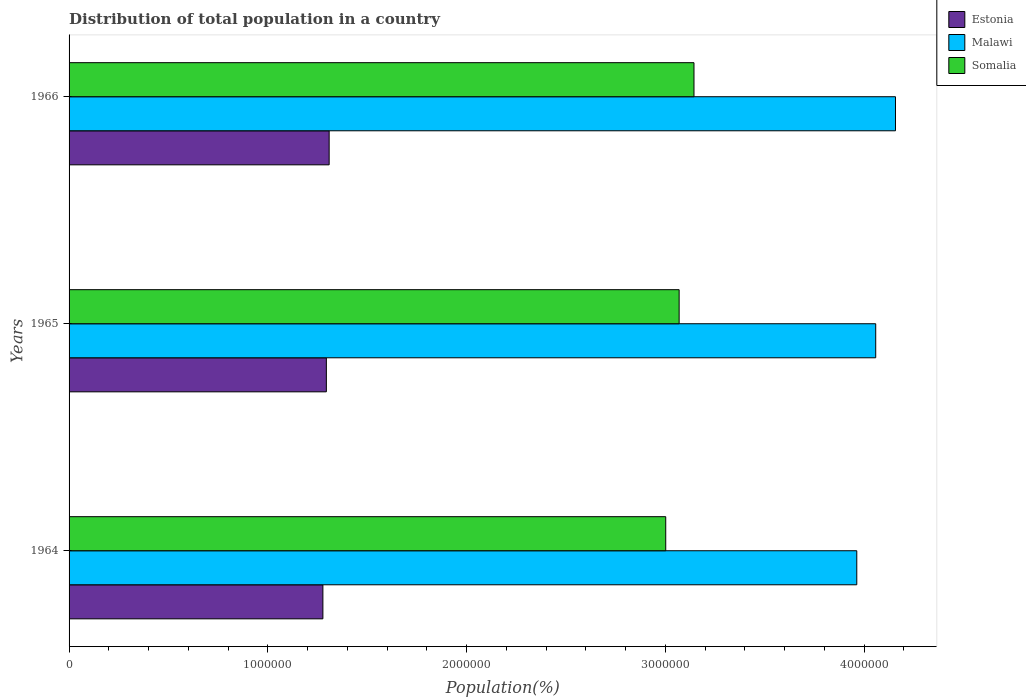Are the number of bars on each tick of the Y-axis equal?
Provide a succinct answer. Yes. How many bars are there on the 3rd tick from the top?
Keep it short and to the point. 3. What is the label of the 1st group of bars from the top?
Provide a succinct answer. 1966. What is the population of in Malawi in 1966?
Give a very brief answer. 4.16e+06. Across all years, what is the maximum population of in Somalia?
Your response must be concise. 3.14e+06. Across all years, what is the minimum population of in Somalia?
Provide a short and direct response. 3.00e+06. In which year was the population of in Somalia maximum?
Offer a terse response. 1966. In which year was the population of in Somalia minimum?
Give a very brief answer. 1964. What is the total population of in Estonia in the graph?
Your response must be concise. 3.88e+06. What is the difference between the population of in Estonia in 1964 and that in 1966?
Provide a short and direct response. -3.15e+04. What is the difference between the population of in Malawi in 1966 and the population of in Estonia in 1964?
Make the answer very short. 2.88e+06. What is the average population of in Malawi per year?
Your answer should be very brief. 4.06e+06. In the year 1964, what is the difference between the population of in Estonia and population of in Malawi?
Keep it short and to the point. -2.69e+06. In how many years, is the population of in Malawi greater than 2200000 %?
Give a very brief answer. 3. What is the ratio of the population of in Somalia in 1964 to that in 1966?
Your response must be concise. 0.95. Is the difference between the population of in Estonia in 1964 and 1966 greater than the difference between the population of in Malawi in 1964 and 1966?
Give a very brief answer. Yes. What is the difference between the highest and the second highest population of in Somalia?
Your response must be concise. 7.47e+04. What is the difference between the highest and the lowest population of in Estonia?
Provide a short and direct response. 3.15e+04. Is the sum of the population of in Somalia in 1965 and 1966 greater than the maximum population of in Malawi across all years?
Your answer should be compact. Yes. What does the 3rd bar from the top in 1964 represents?
Offer a terse response. Estonia. What does the 3rd bar from the bottom in 1964 represents?
Provide a short and direct response. Somalia. How many years are there in the graph?
Your response must be concise. 3. What is the difference between two consecutive major ticks on the X-axis?
Ensure brevity in your answer.  1.00e+06. Are the values on the major ticks of X-axis written in scientific E-notation?
Give a very brief answer. No. Does the graph contain grids?
Your answer should be very brief. No. How many legend labels are there?
Ensure brevity in your answer.  3. What is the title of the graph?
Give a very brief answer. Distribution of total population in a country. What is the label or title of the X-axis?
Make the answer very short. Population(%). What is the Population(%) in Estonia in 1964?
Your answer should be very brief. 1.28e+06. What is the Population(%) in Malawi in 1964?
Ensure brevity in your answer.  3.96e+06. What is the Population(%) of Somalia in 1964?
Give a very brief answer. 3.00e+06. What is the Population(%) of Estonia in 1965?
Your response must be concise. 1.29e+06. What is the Population(%) in Malawi in 1965?
Keep it short and to the point. 4.06e+06. What is the Population(%) of Somalia in 1965?
Your answer should be compact. 3.07e+06. What is the Population(%) in Estonia in 1966?
Offer a very short reply. 1.31e+06. What is the Population(%) of Malawi in 1966?
Your answer should be very brief. 4.16e+06. What is the Population(%) of Somalia in 1966?
Make the answer very short. 3.14e+06. Across all years, what is the maximum Population(%) in Estonia?
Keep it short and to the point. 1.31e+06. Across all years, what is the maximum Population(%) in Malawi?
Provide a succinct answer. 4.16e+06. Across all years, what is the maximum Population(%) of Somalia?
Your response must be concise. 3.14e+06. Across all years, what is the minimum Population(%) of Estonia?
Your response must be concise. 1.28e+06. Across all years, what is the minimum Population(%) of Malawi?
Your response must be concise. 3.96e+06. Across all years, what is the minimum Population(%) of Somalia?
Offer a terse response. 3.00e+06. What is the total Population(%) of Estonia in the graph?
Your response must be concise. 3.88e+06. What is the total Population(%) of Malawi in the graph?
Provide a short and direct response. 1.22e+07. What is the total Population(%) of Somalia in the graph?
Provide a succinct answer. 9.22e+06. What is the difference between the Population(%) in Estonia in 1964 and that in 1965?
Your response must be concise. -1.75e+04. What is the difference between the Population(%) in Malawi in 1964 and that in 1965?
Provide a short and direct response. -9.53e+04. What is the difference between the Population(%) of Somalia in 1964 and that in 1965?
Offer a very short reply. -6.74e+04. What is the difference between the Population(%) of Estonia in 1964 and that in 1966?
Provide a succinct answer. -3.15e+04. What is the difference between the Population(%) of Malawi in 1964 and that in 1966?
Offer a terse response. -1.95e+05. What is the difference between the Population(%) of Somalia in 1964 and that in 1966?
Make the answer very short. -1.42e+05. What is the difference between the Population(%) in Estonia in 1965 and that in 1966?
Keep it short and to the point. -1.40e+04. What is the difference between the Population(%) in Malawi in 1965 and that in 1966?
Offer a very short reply. -9.95e+04. What is the difference between the Population(%) in Somalia in 1965 and that in 1966?
Offer a terse response. -7.47e+04. What is the difference between the Population(%) in Estonia in 1964 and the Population(%) in Malawi in 1965?
Keep it short and to the point. -2.78e+06. What is the difference between the Population(%) in Estonia in 1964 and the Population(%) in Somalia in 1965?
Your answer should be compact. -1.79e+06. What is the difference between the Population(%) of Malawi in 1964 and the Population(%) of Somalia in 1965?
Give a very brief answer. 8.94e+05. What is the difference between the Population(%) of Estonia in 1964 and the Population(%) of Malawi in 1966?
Your answer should be very brief. -2.88e+06. What is the difference between the Population(%) in Estonia in 1964 and the Population(%) in Somalia in 1966?
Your response must be concise. -1.87e+06. What is the difference between the Population(%) of Malawi in 1964 and the Population(%) of Somalia in 1966?
Your answer should be very brief. 8.19e+05. What is the difference between the Population(%) in Estonia in 1965 and the Population(%) in Malawi in 1966?
Your answer should be very brief. -2.86e+06. What is the difference between the Population(%) of Estonia in 1965 and the Population(%) of Somalia in 1966?
Make the answer very short. -1.85e+06. What is the difference between the Population(%) in Malawi in 1965 and the Population(%) in Somalia in 1966?
Provide a short and direct response. 9.14e+05. What is the average Population(%) in Estonia per year?
Provide a succinct answer. 1.29e+06. What is the average Population(%) in Malawi per year?
Your answer should be very brief. 4.06e+06. What is the average Population(%) in Somalia per year?
Give a very brief answer. 3.07e+06. In the year 1964, what is the difference between the Population(%) in Estonia and Population(%) in Malawi?
Provide a short and direct response. -2.69e+06. In the year 1964, what is the difference between the Population(%) of Estonia and Population(%) of Somalia?
Provide a short and direct response. -1.73e+06. In the year 1964, what is the difference between the Population(%) of Malawi and Population(%) of Somalia?
Your answer should be compact. 9.61e+05. In the year 1965, what is the difference between the Population(%) of Estonia and Population(%) of Malawi?
Your answer should be very brief. -2.76e+06. In the year 1965, what is the difference between the Population(%) in Estonia and Population(%) in Somalia?
Your answer should be very brief. -1.77e+06. In the year 1965, what is the difference between the Population(%) in Malawi and Population(%) in Somalia?
Provide a succinct answer. 9.89e+05. In the year 1966, what is the difference between the Population(%) of Estonia and Population(%) of Malawi?
Ensure brevity in your answer.  -2.85e+06. In the year 1966, what is the difference between the Population(%) of Estonia and Population(%) of Somalia?
Your answer should be compact. -1.84e+06. In the year 1966, what is the difference between the Population(%) of Malawi and Population(%) of Somalia?
Your response must be concise. 1.01e+06. What is the ratio of the Population(%) in Estonia in 1964 to that in 1965?
Offer a very short reply. 0.99. What is the ratio of the Population(%) of Malawi in 1964 to that in 1965?
Offer a terse response. 0.98. What is the ratio of the Population(%) of Estonia in 1964 to that in 1966?
Your response must be concise. 0.98. What is the ratio of the Population(%) in Malawi in 1964 to that in 1966?
Keep it short and to the point. 0.95. What is the ratio of the Population(%) of Somalia in 1964 to that in 1966?
Offer a very short reply. 0.95. What is the ratio of the Population(%) in Estonia in 1965 to that in 1966?
Your answer should be compact. 0.99. What is the ratio of the Population(%) of Malawi in 1965 to that in 1966?
Offer a terse response. 0.98. What is the ratio of the Population(%) of Somalia in 1965 to that in 1966?
Ensure brevity in your answer.  0.98. What is the difference between the highest and the second highest Population(%) of Estonia?
Make the answer very short. 1.40e+04. What is the difference between the highest and the second highest Population(%) of Malawi?
Offer a very short reply. 9.95e+04. What is the difference between the highest and the second highest Population(%) in Somalia?
Offer a terse response. 7.47e+04. What is the difference between the highest and the lowest Population(%) in Estonia?
Offer a very short reply. 3.15e+04. What is the difference between the highest and the lowest Population(%) in Malawi?
Ensure brevity in your answer.  1.95e+05. What is the difference between the highest and the lowest Population(%) of Somalia?
Ensure brevity in your answer.  1.42e+05. 